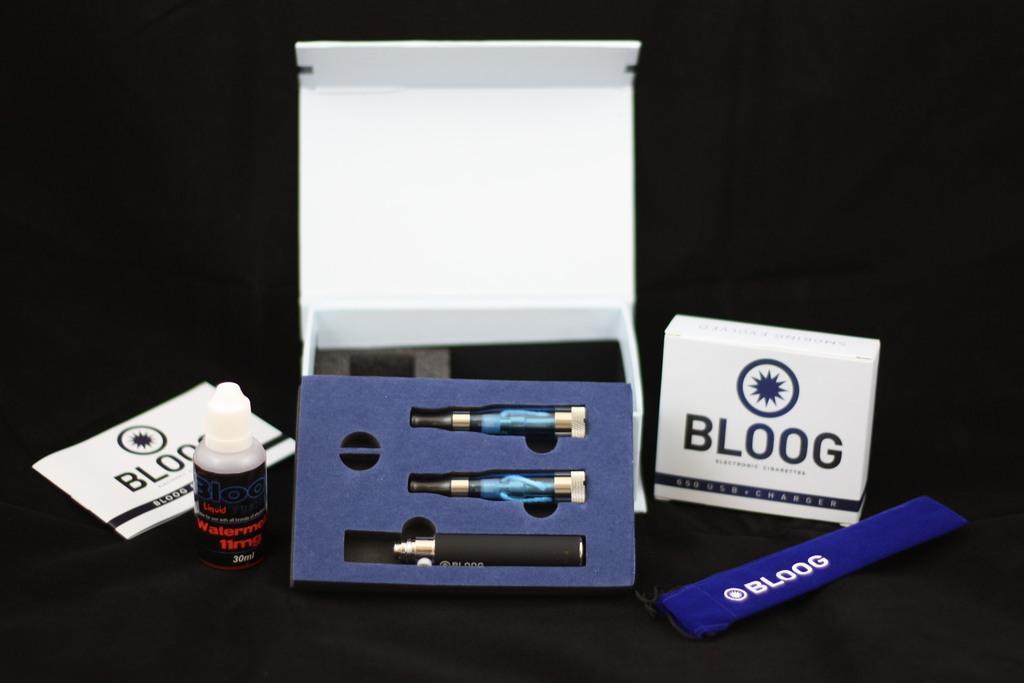Could you give a brief overview of what you see in this image? In this picture we can see a book, tube, boxes and some objects and in the background it is dark. 